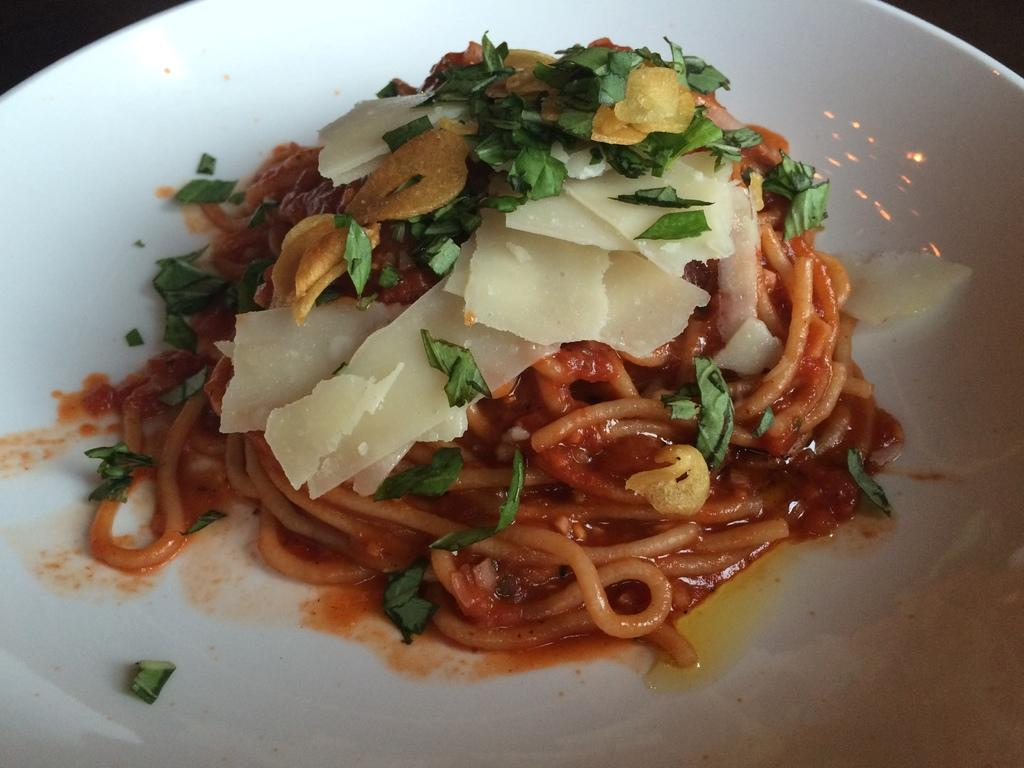What is present on the plate in the image? There is food in a plate in the image. What type of trade is being conducted in the image? There is no indication of any trade being conducted in the image; it simply shows a plate of food. What advice is being given in the image? There is no advice being given in the image; it simply shows a plate of food. 